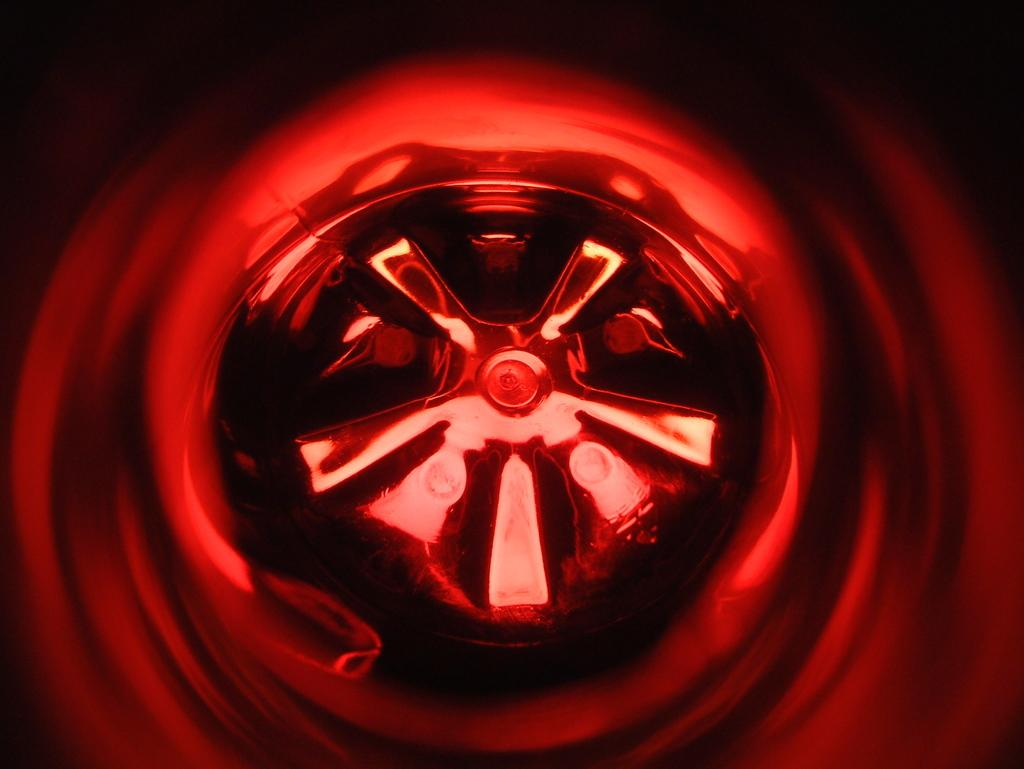What type of image is being described? The image is animated. What can be seen in the middle of the animated image? There is a wheel in the middle of the image. What color lighting is present around the wheel? There is red color lighting around the wheel. What type of hammer is being used to bite into the wheel in the image? There is no hammer or biting action present in the image; it features an animated wheel with red color lighting around it. 